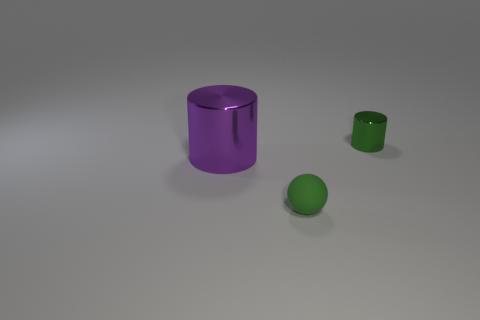What number of purple things have the same material as the small green cylinder?
Offer a very short reply. 1. Is the number of green rubber balls that are left of the big purple metal object the same as the number of green metallic cubes?
Provide a short and direct response. Yes. There is a tiny ball that is the same color as the small shiny thing; what is its material?
Your answer should be very brief. Rubber. Do the purple cylinder and the object that is on the right side of the small green sphere have the same size?
Make the answer very short. No. How many other things are there of the same size as the purple thing?
Ensure brevity in your answer.  0. What number of other objects are there of the same color as the tiny matte object?
Your answer should be very brief. 1. Is there any other thing that is the same size as the green metal thing?
Ensure brevity in your answer.  Yes. How many other things are the same shape as the small green rubber object?
Your answer should be compact. 0. Does the green shiny cylinder have the same size as the purple metallic cylinder?
Ensure brevity in your answer.  No. Are there any big red spheres?
Your answer should be compact. No. 